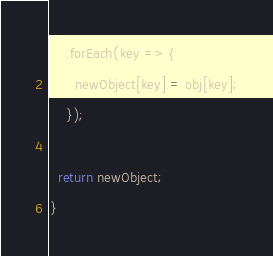<code> <loc_0><loc_0><loc_500><loc_500><_TypeScript_>    .forEach(key => {
      newObject[key] = obj[key];
    });

  return newObject;
}
</code> 